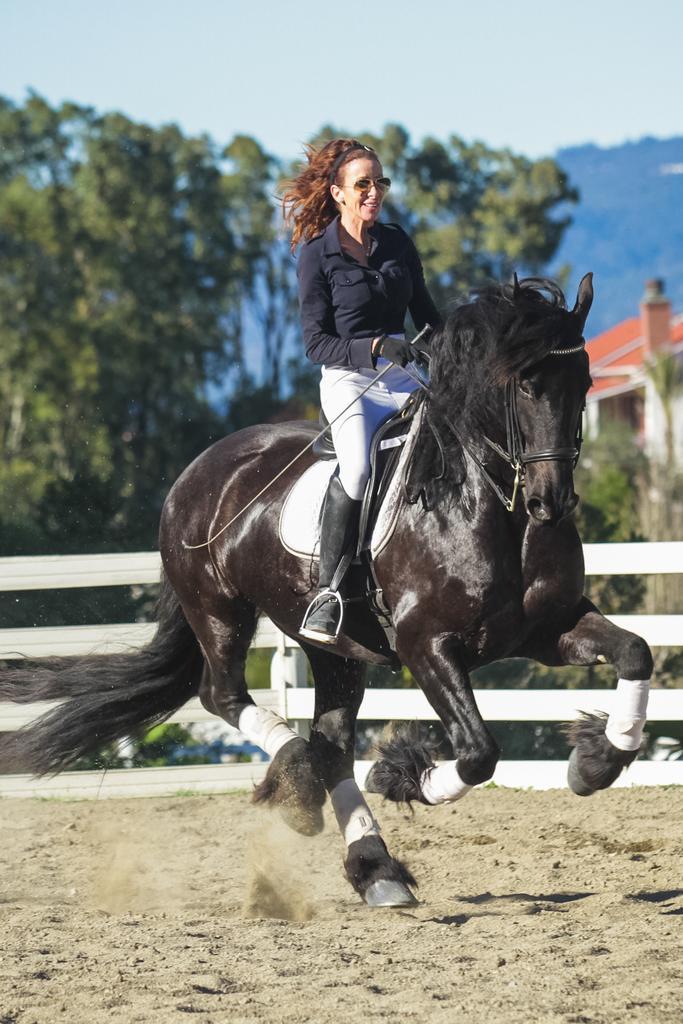Describe this image in one or two sentences. In this image, I can see a woman riding a horse. Behind the horse, I can see the wooden fence. In the background, there are trees, a building and the sky. 